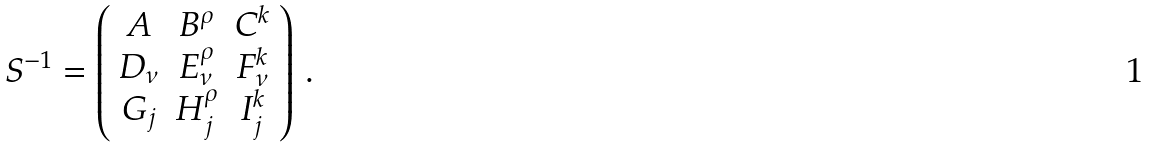<formula> <loc_0><loc_0><loc_500><loc_500>S ^ { - 1 } = \left ( \begin{array} { c c c } A & B ^ { \rho } & C ^ { k } \\ D _ { \nu } & E _ { \nu } ^ { \rho } & F _ { \nu } ^ { k } \\ G _ { j } & H _ { j } ^ { \rho } & I _ { j } ^ { k } \\ \end{array} \right ) \, .</formula> 